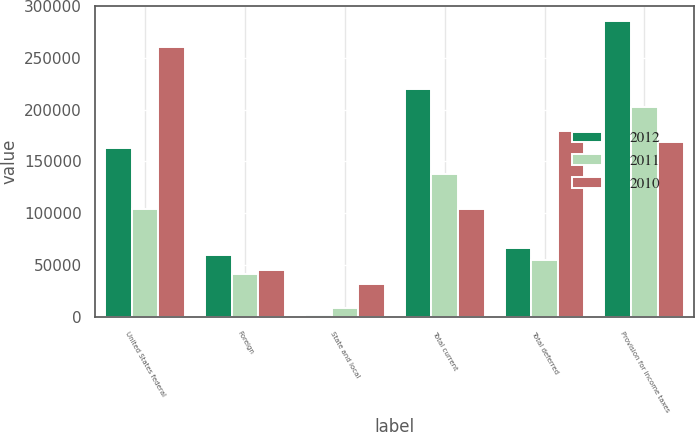<chart> <loc_0><loc_0><loc_500><loc_500><stacked_bar_chart><ecel><fcel>United States federal<fcel>Foreign<fcel>State and local<fcel>Total current<fcel>Total deferred<fcel>Provision for income taxes<nl><fcel>2012<fcel>162574<fcel>59255<fcel>2244<fcel>219585<fcel>66434<fcel>286019<nl><fcel>2011<fcel>104587<fcel>41724<fcel>8769<fcel>137542<fcel>55273<fcel>202383<nl><fcel>2010<fcel>260118<fcel>44869<fcel>31866<fcel>104587<fcel>179490<fcel>168471<nl></chart> 